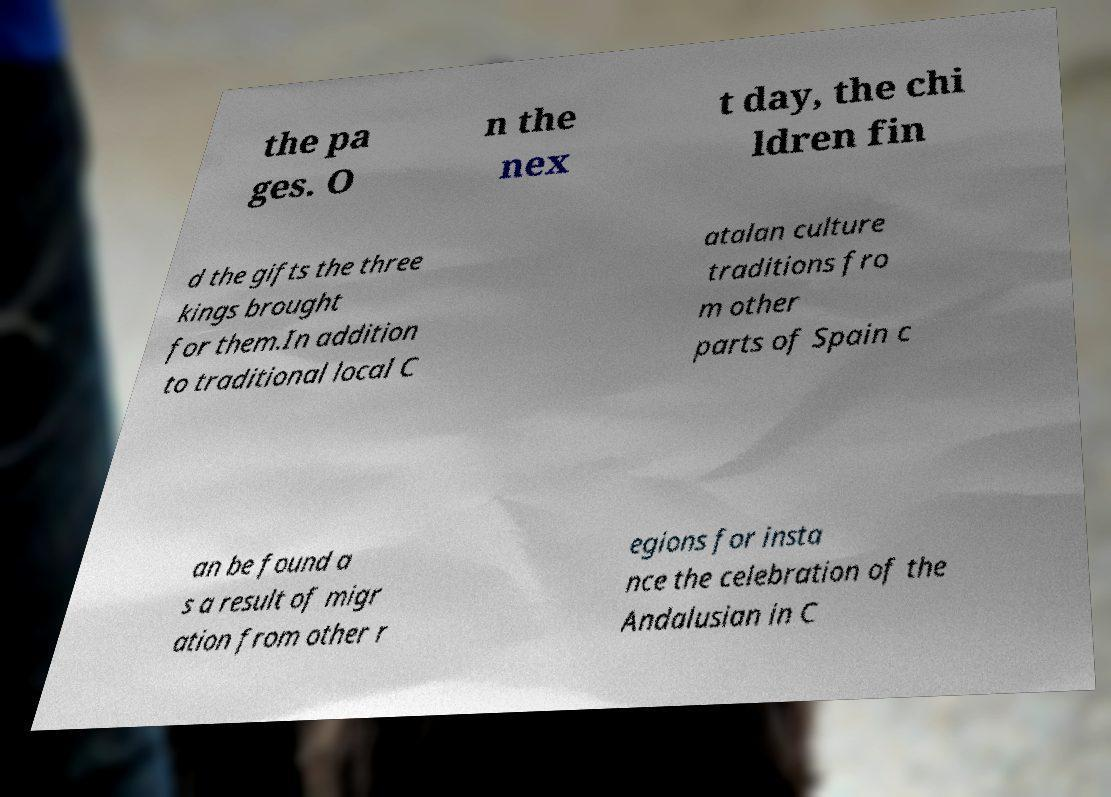Can you accurately transcribe the text from the provided image for me? the pa ges. O n the nex t day, the chi ldren fin d the gifts the three kings brought for them.In addition to traditional local C atalan culture traditions fro m other parts of Spain c an be found a s a result of migr ation from other r egions for insta nce the celebration of the Andalusian in C 